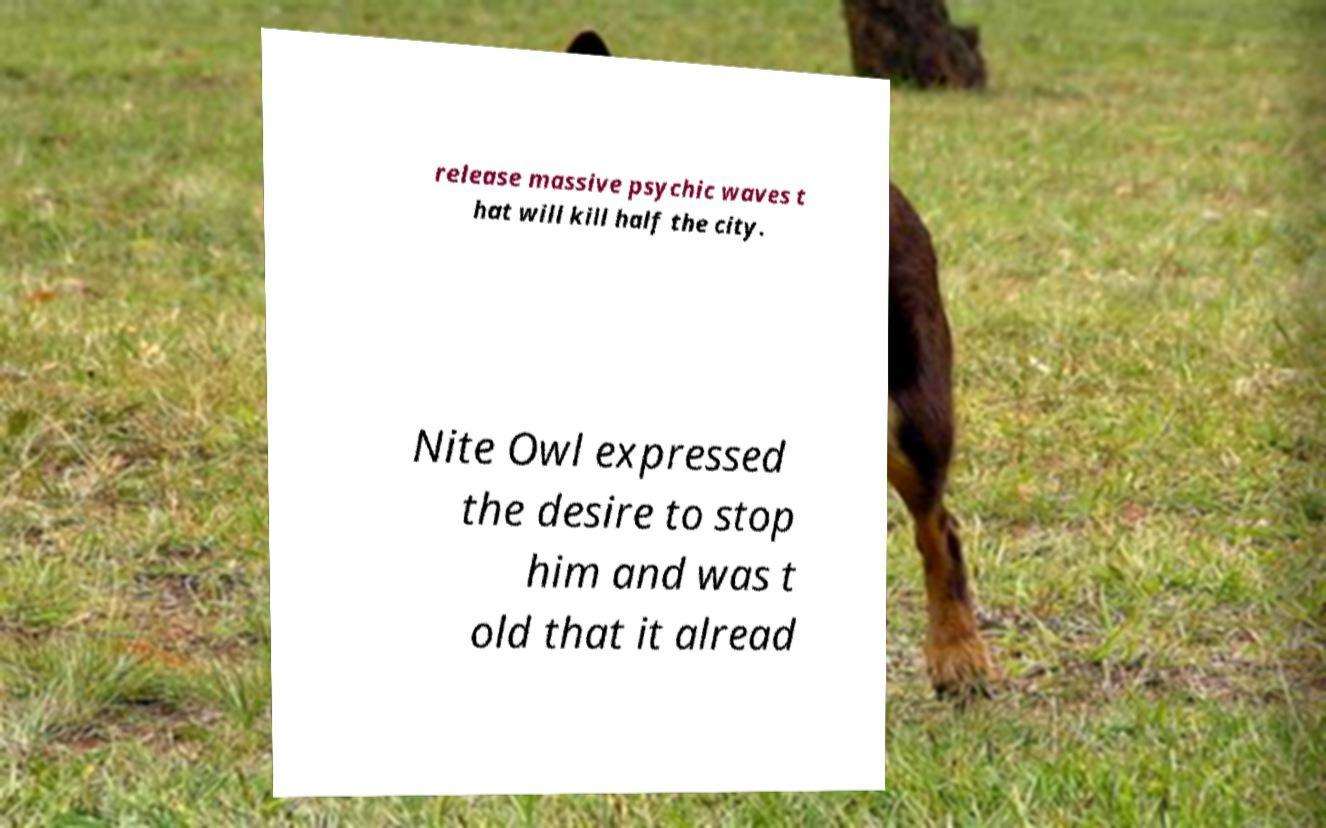What messages or text are displayed in this image? I need them in a readable, typed format. release massive psychic waves t hat will kill half the city. Nite Owl expressed the desire to stop him and was t old that it alread 